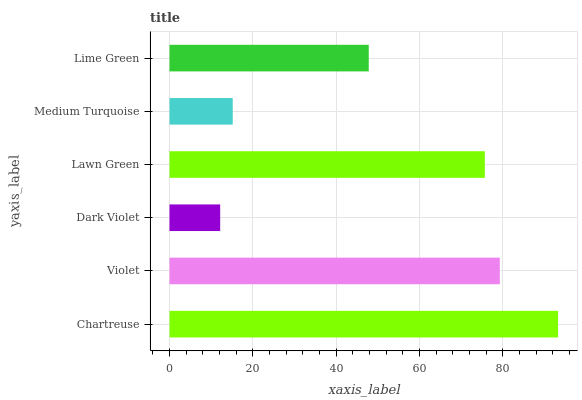Is Dark Violet the minimum?
Answer yes or no. Yes. Is Chartreuse the maximum?
Answer yes or no. Yes. Is Violet the minimum?
Answer yes or no. No. Is Violet the maximum?
Answer yes or no. No. Is Chartreuse greater than Violet?
Answer yes or no. Yes. Is Violet less than Chartreuse?
Answer yes or no. Yes. Is Violet greater than Chartreuse?
Answer yes or no. No. Is Chartreuse less than Violet?
Answer yes or no. No. Is Lawn Green the high median?
Answer yes or no. Yes. Is Lime Green the low median?
Answer yes or no. Yes. Is Medium Turquoise the high median?
Answer yes or no. No. Is Violet the low median?
Answer yes or no. No. 